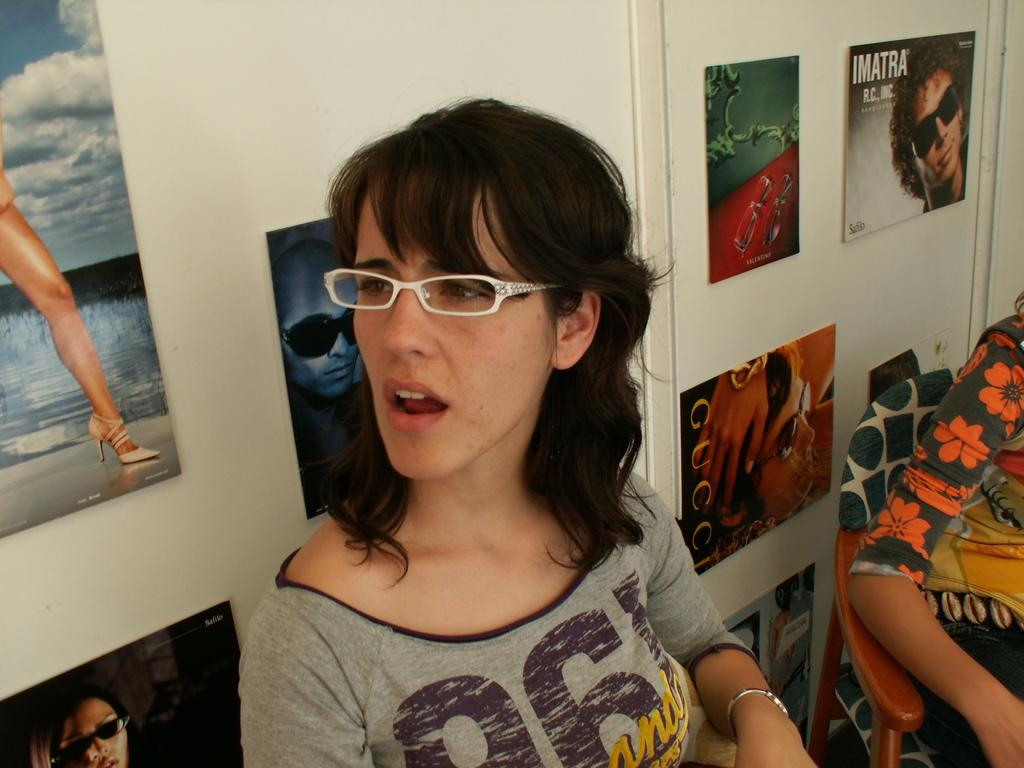Who is present in the image? There is a lady in the image. Can you describe the appearance of another person in the image? There is a person partially covered in the image. What can be seen on the wall in the image? There is a wall with posters in the image. What type of furniture is visible in the image? There is a chair in the image. How many beds are visible in the image? There are no beds present in the image. 